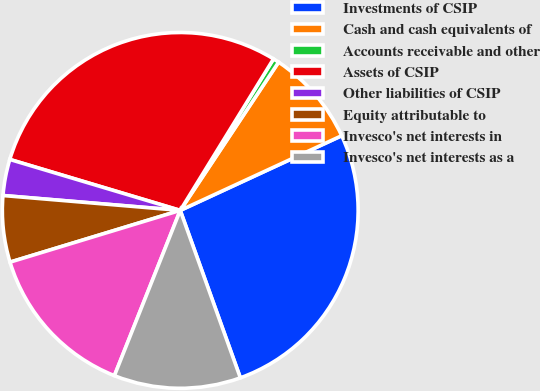<chart> <loc_0><loc_0><loc_500><loc_500><pie_chart><fcel>Investments of CSIP<fcel>Cash and cash equivalents of<fcel>Accounts receivable and other<fcel>Assets of CSIP<fcel>Other liabilities of CSIP<fcel>Equity attributable to<fcel>Invesco's net interests in<fcel>Invesco's net interests as a<nl><fcel>26.41%<fcel>8.78%<fcel>0.54%<fcel>29.16%<fcel>3.29%<fcel>6.03%<fcel>14.27%<fcel>11.52%<nl></chart> 